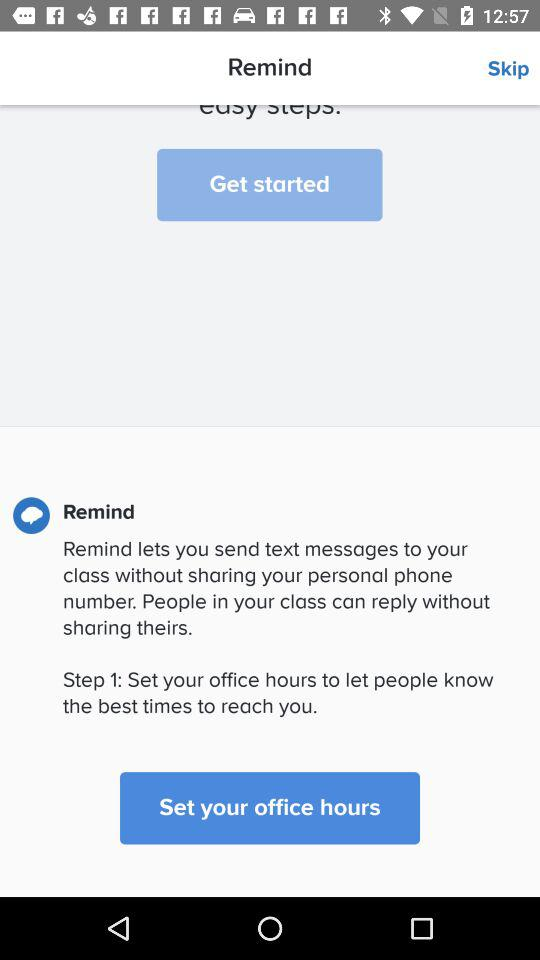What is the name of the application? The application name is "Remind". 